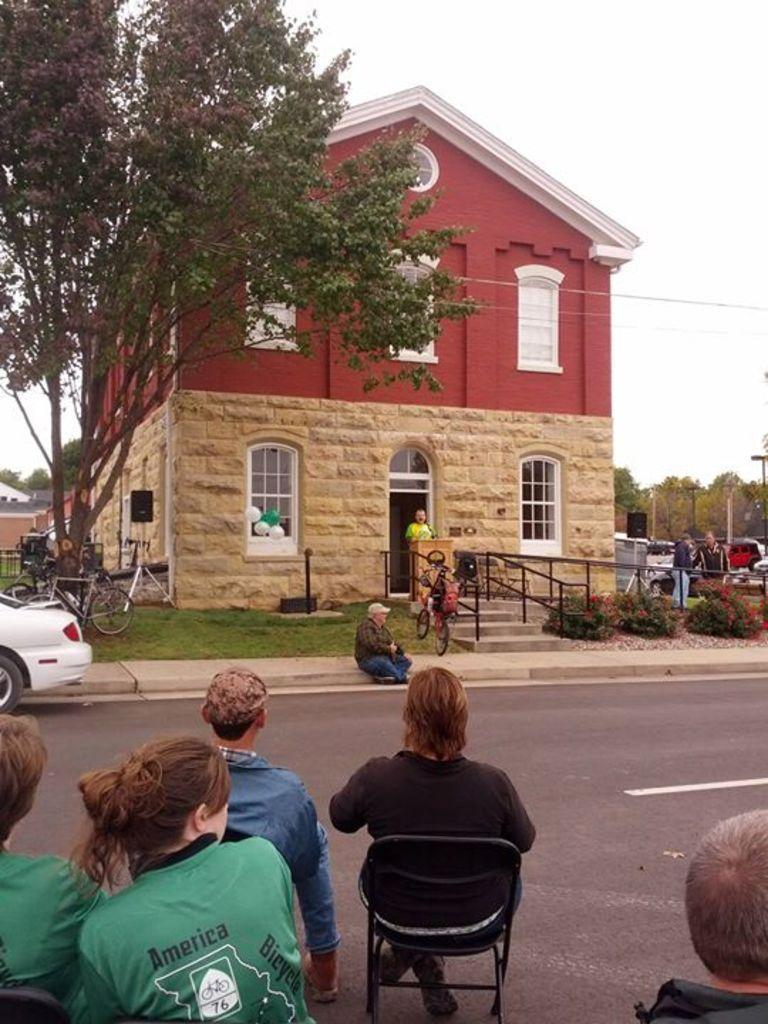Can you describe this image briefly? In this image I can see the group of people sitting on the chairs and they are on the road. There is also a car on the road. In front of them there is a building,tree and the sky. 